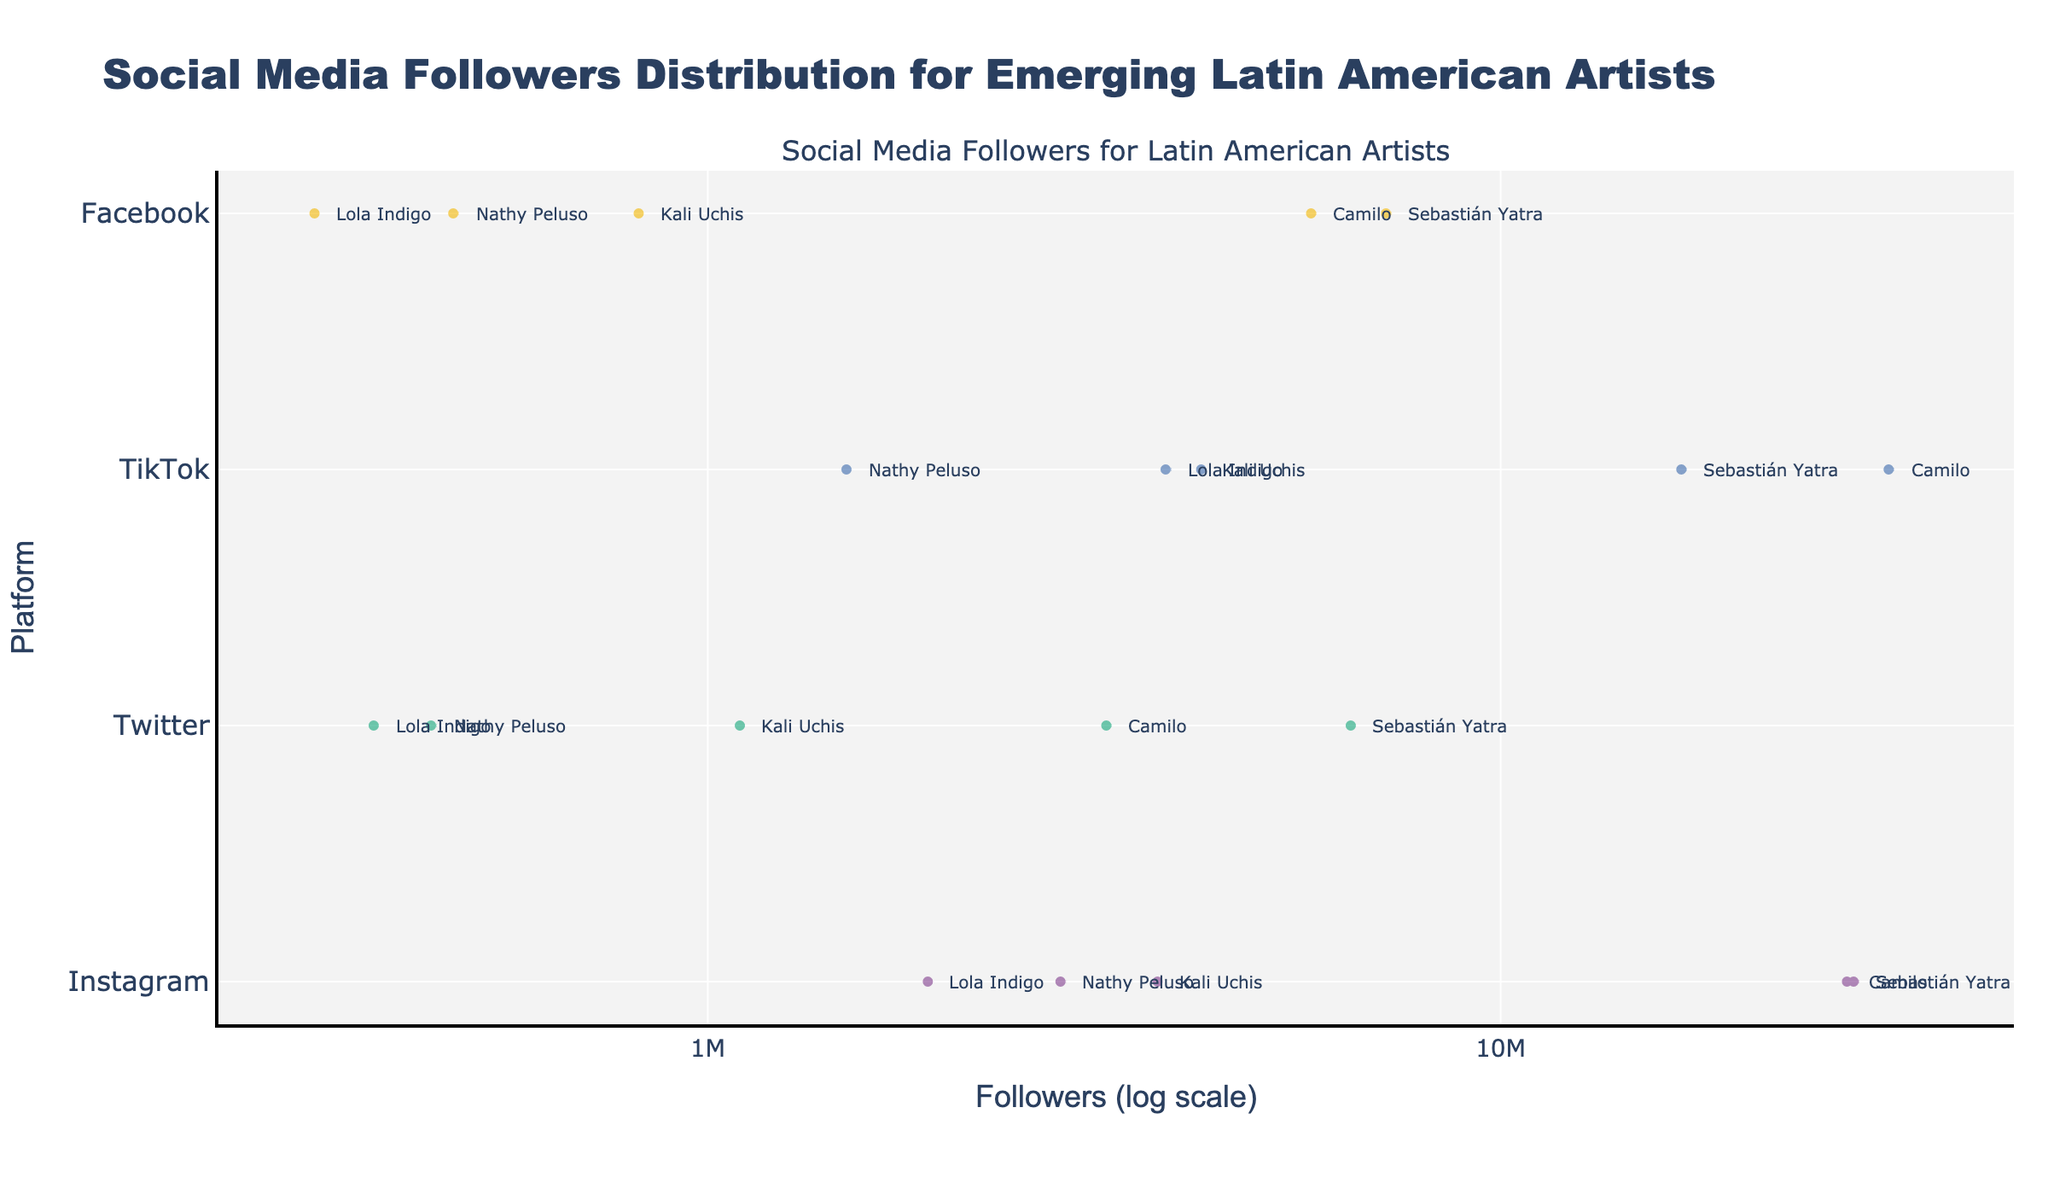What is the title of the figure? The title of the figure is prominently displayed at the top.
Answer: Social Media Followers Distribution for Emerging Latin American Artists Which platform has the highest median number of followers? By observing the visual median represented by the horizontal line inside the box of the violin plot, you can determine which platform's median follows the furthest right (largest value), and TikTok's median line appears to be the furthest to the right indicating higher followers compared to others.
Answer: TikTok What is the log scale value representing 10 million followers on the x-axis? The log scale value can be obtained by finding the tick label '10M' on the x-axis.
Answer: 7 Which artist has the most followers on Instagram? The longest data point on the Instagram violin plot indicates the artist with the most followers. Camilo has the highest data point for Instagram.
Answer: Camilo Compare the number of followers for Sebastián Yatra on Facebook to his followers on TikTok in terms of log scale values. Find Sebastián Yatra's points on both Facebook and TikTok violin plots. On Facebook, his followers are around 7.2M (log ≈ 6.86) and on TikTok, he has 17M (log ≈ 7.23). Comparing the log values we see that 7.23 > 6.86.
Answer: TikTok is greater Which platform shows the greatest variability in follower counts? Variability can be assessed by the spread of the data points in the violin plot. The platform with the widest spread indicates the highest variability, which appears to be Instagram.
Answer: Instagram How many platforms have Camilo's followers' data included in the figure? By counting all distinct platforms listed as y-axis categories containing Camilo's annotations.
Answer: 4 Which artist has the least number of followers on Twitter? By looking at the lowest point of the Twitter violin plot and matching it with the artist's annotation, which shows Nathy Peluso has the smallest value.
Answer: Nathy Peluso What is the order of platforms from highest to lowest in terms of the most considerable number of followers of any artist? By examining the furthest point on the right in each violin plot for each platform, the order from highest follower count to the lowest is observed: TikTok, Instagram, Facebook, Twitter.
Answer: TikTok, Instagram, Facebook, Twitter What box plots with median values indicate higher log scale follower counts between Instagram and Facebook? The median line in Instagram appears to be visually located further right than the median line of Facebook when compared.
Answer: Instagram 